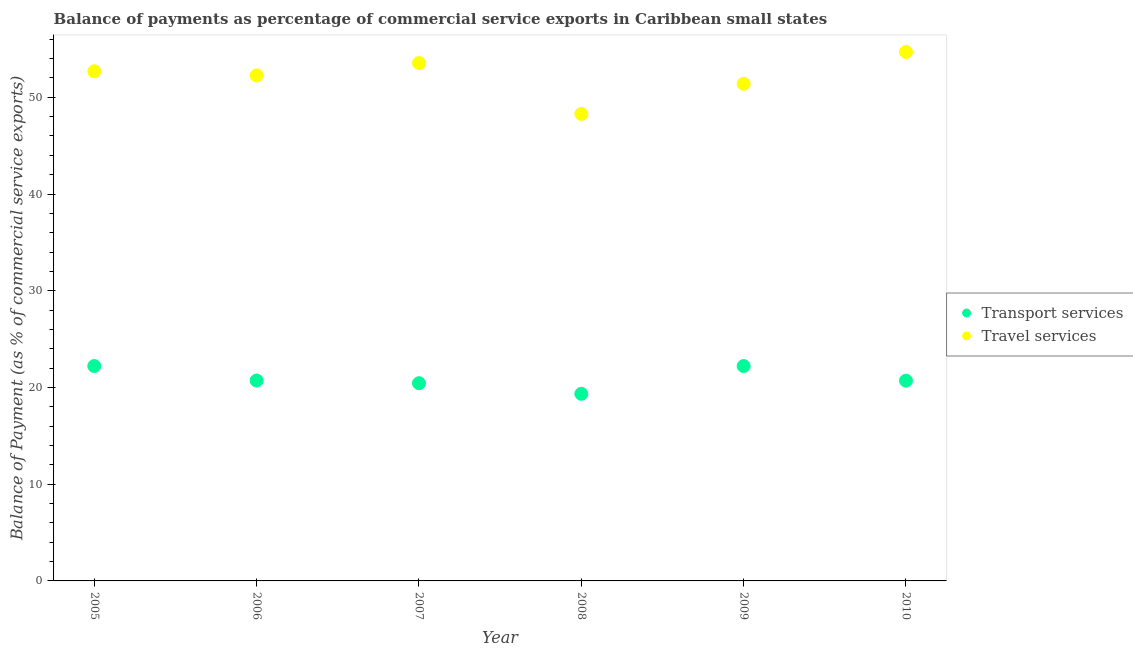What is the balance of payments of transport services in 2006?
Make the answer very short. 20.72. Across all years, what is the maximum balance of payments of transport services?
Make the answer very short. 22.22. Across all years, what is the minimum balance of payments of transport services?
Make the answer very short. 19.34. What is the total balance of payments of transport services in the graph?
Provide a short and direct response. 125.64. What is the difference between the balance of payments of travel services in 2006 and that in 2010?
Keep it short and to the point. -2.42. What is the difference between the balance of payments of travel services in 2010 and the balance of payments of transport services in 2005?
Provide a succinct answer. 32.47. What is the average balance of payments of transport services per year?
Provide a succinct answer. 20.94. In the year 2010, what is the difference between the balance of payments of travel services and balance of payments of transport services?
Provide a short and direct response. 33.98. In how many years, is the balance of payments of travel services greater than 6 %?
Make the answer very short. 6. What is the ratio of the balance of payments of travel services in 2006 to that in 2009?
Ensure brevity in your answer.  1.02. Is the difference between the balance of payments of transport services in 2007 and 2010 greater than the difference between the balance of payments of travel services in 2007 and 2010?
Your answer should be very brief. Yes. What is the difference between the highest and the second highest balance of payments of travel services?
Provide a short and direct response. 1.15. What is the difference between the highest and the lowest balance of payments of transport services?
Offer a very short reply. 2.87. Is the balance of payments of travel services strictly greater than the balance of payments of transport services over the years?
Provide a short and direct response. Yes. How many dotlines are there?
Ensure brevity in your answer.  2. How many years are there in the graph?
Provide a succinct answer. 6. What is the difference between two consecutive major ticks on the Y-axis?
Your answer should be compact. 10. Does the graph contain any zero values?
Your answer should be compact. No. Does the graph contain grids?
Offer a terse response. No. Where does the legend appear in the graph?
Your response must be concise. Center right. How are the legend labels stacked?
Ensure brevity in your answer.  Vertical. What is the title of the graph?
Offer a very short reply. Balance of payments as percentage of commercial service exports in Caribbean small states. Does "Manufacturing industries and construction" appear as one of the legend labels in the graph?
Provide a short and direct response. No. What is the label or title of the Y-axis?
Provide a short and direct response. Balance of Payment (as % of commercial service exports). What is the Balance of Payment (as % of commercial service exports) of Transport services in 2005?
Your answer should be very brief. 22.22. What is the Balance of Payment (as % of commercial service exports) in Travel services in 2005?
Provide a succinct answer. 52.69. What is the Balance of Payment (as % of commercial service exports) in Transport services in 2006?
Your answer should be compact. 20.72. What is the Balance of Payment (as % of commercial service exports) of Travel services in 2006?
Your response must be concise. 52.27. What is the Balance of Payment (as % of commercial service exports) in Transport services in 2007?
Offer a terse response. 20.44. What is the Balance of Payment (as % of commercial service exports) of Travel services in 2007?
Offer a very short reply. 53.54. What is the Balance of Payment (as % of commercial service exports) in Transport services in 2008?
Your answer should be very brief. 19.34. What is the Balance of Payment (as % of commercial service exports) of Travel services in 2008?
Keep it short and to the point. 48.28. What is the Balance of Payment (as % of commercial service exports) in Transport services in 2009?
Make the answer very short. 22.22. What is the Balance of Payment (as % of commercial service exports) of Travel services in 2009?
Offer a very short reply. 51.4. What is the Balance of Payment (as % of commercial service exports) in Transport services in 2010?
Make the answer very short. 20.71. What is the Balance of Payment (as % of commercial service exports) in Travel services in 2010?
Ensure brevity in your answer.  54.69. Across all years, what is the maximum Balance of Payment (as % of commercial service exports) in Transport services?
Provide a short and direct response. 22.22. Across all years, what is the maximum Balance of Payment (as % of commercial service exports) in Travel services?
Give a very brief answer. 54.69. Across all years, what is the minimum Balance of Payment (as % of commercial service exports) of Transport services?
Your response must be concise. 19.34. Across all years, what is the minimum Balance of Payment (as % of commercial service exports) of Travel services?
Your answer should be very brief. 48.28. What is the total Balance of Payment (as % of commercial service exports) in Transport services in the graph?
Your response must be concise. 125.64. What is the total Balance of Payment (as % of commercial service exports) in Travel services in the graph?
Your response must be concise. 312.86. What is the difference between the Balance of Payment (as % of commercial service exports) of Transport services in 2005 and that in 2006?
Your response must be concise. 1.5. What is the difference between the Balance of Payment (as % of commercial service exports) in Travel services in 2005 and that in 2006?
Provide a short and direct response. 0.42. What is the difference between the Balance of Payment (as % of commercial service exports) of Transport services in 2005 and that in 2007?
Provide a short and direct response. 1.78. What is the difference between the Balance of Payment (as % of commercial service exports) in Travel services in 2005 and that in 2007?
Ensure brevity in your answer.  -0.85. What is the difference between the Balance of Payment (as % of commercial service exports) in Transport services in 2005 and that in 2008?
Offer a very short reply. 2.87. What is the difference between the Balance of Payment (as % of commercial service exports) in Travel services in 2005 and that in 2008?
Offer a very short reply. 4.41. What is the difference between the Balance of Payment (as % of commercial service exports) in Transport services in 2005 and that in 2009?
Give a very brief answer. 0. What is the difference between the Balance of Payment (as % of commercial service exports) of Travel services in 2005 and that in 2009?
Provide a succinct answer. 1.29. What is the difference between the Balance of Payment (as % of commercial service exports) in Transport services in 2005 and that in 2010?
Ensure brevity in your answer.  1.51. What is the difference between the Balance of Payment (as % of commercial service exports) of Travel services in 2005 and that in 2010?
Make the answer very short. -1.99. What is the difference between the Balance of Payment (as % of commercial service exports) in Transport services in 2006 and that in 2007?
Provide a succinct answer. 0.28. What is the difference between the Balance of Payment (as % of commercial service exports) in Travel services in 2006 and that in 2007?
Ensure brevity in your answer.  -1.27. What is the difference between the Balance of Payment (as % of commercial service exports) of Transport services in 2006 and that in 2008?
Ensure brevity in your answer.  1.37. What is the difference between the Balance of Payment (as % of commercial service exports) of Travel services in 2006 and that in 2008?
Your answer should be compact. 3.98. What is the difference between the Balance of Payment (as % of commercial service exports) in Transport services in 2006 and that in 2009?
Offer a terse response. -1.5. What is the difference between the Balance of Payment (as % of commercial service exports) in Travel services in 2006 and that in 2009?
Your answer should be very brief. 0.87. What is the difference between the Balance of Payment (as % of commercial service exports) of Travel services in 2006 and that in 2010?
Your answer should be compact. -2.42. What is the difference between the Balance of Payment (as % of commercial service exports) in Transport services in 2007 and that in 2008?
Your response must be concise. 1.1. What is the difference between the Balance of Payment (as % of commercial service exports) in Travel services in 2007 and that in 2008?
Your response must be concise. 5.26. What is the difference between the Balance of Payment (as % of commercial service exports) in Transport services in 2007 and that in 2009?
Your answer should be compact. -1.78. What is the difference between the Balance of Payment (as % of commercial service exports) of Travel services in 2007 and that in 2009?
Your response must be concise. 2.14. What is the difference between the Balance of Payment (as % of commercial service exports) in Transport services in 2007 and that in 2010?
Provide a succinct answer. -0.27. What is the difference between the Balance of Payment (as % of commercial service exports) in Travel services in 2007 and that in 2010?
Give a very brief answer. -1.15. What is the difference between the Balance of Payment (as % of commercial service exports) of Transport services in 2008 and that in 2009?
Make the answer very short. -2.87. What is the difference between the Balance of Payment (as % of commercial service exports) in Travel services in 2008 and that in 2009?
Offer a very short reply. -3.12. What is the difference between the Balance of Payment (as % of commercial service exports) in Transport services in 2008 and that in 2010?
Give a very brief answer. -1.36. What is the difference between the Balance of Payment (as % of commercial service exports) of Travel services in 2008 and that in 2010?
Give a very brief answer. -6.4. What is the difference between the Balance of Payment (as % of commercial service exports) in Transport services in 2009 and that in 2010?
Make the answer very short. 1.51. What is the difference between the Balance of Payment (as % of commercial service exports) in Travel services in 2009 and that in 2010?
Your answer should be very brief. -3.29. What is the difference between the Balance of Payment (as % of commercial service exports) of Transport services in 2005 and the Balance of Payment (as % of commercial service exports) of Travel services in 2006?
Offer a very short reply. -30.05. What is the difference between the Balance of Payment (as % of commercial service exports) in Transport services in 2005 and the Balance of Payment (as % of commercial service exports) in Travel services in 2007?
Your answer should be very brief. -31.32. What is the difference between the Balance of Payment (as % of commercial service exports) of Transport services in 2005 and the Balance of Payment (as % of commercial service exports) of Travel services in 2008?
Provide a short and direct response. -26.07. What is the difference between the Balance of Payment (as % of commercial service exports) of Transport services in 2005 and the Balance of Payment (as % of commercial service exports) of Travel services in 2009?
Ensure brevity in your answer.  -29.18. What is the difference between the Balance of Payment (as % of commercial service exports) in Transport services in 2005 and the Balance of Payment (as % of commercial service exports) in Travel services in 2010?
Give a very brief answer. -32.47. What is the difference between the Balance of Payment (as % of commercial service exports) of Transport services in 2006 and the Balance of Payment (as % of commercial service exports) of Travel services in 2007?
Provide a succinct answer. -32.82. What is the difference between the Balance of Payment (as % of commercial service exports) of Transport services in 2006 and the Balance of Payment (as % of commercial service exports) of Travel services in 2008?
Ensure brevity in your answer.  -27.57. What is the difference between the Balance of Payment (as % of commercial service exports) in Transport services in 2006 and the Balance of Payment (as % of commercial service exports) in Travel services in 2009?
Your answer should be very brief. -30.68. What is the difference between the Balance of Payment (as % of commercial service exports) in Transport services in 2006 and the Balance of Payment (as % of commercial service exports) in Travel services in 2010?
Provide a succinct answer. -33.97. What is the difference between the Balance of Payment (as % of commercial service exports) of Transport services in 2007 and the Balance of Payment (as % of commercial service exports) of Travel services in 2008?
Ensure brevity in your answer.  -27.84. What is the difference between the Balance of Payment (as % of commercial service exports) in Transport services in 2007 and the Balance of Payment (as % of commercial service exports) in Travel services in 2009?
Give a very brief answer. -30.96. What is the difference between the Balance of Payment (as % of commercial service exports) of Transport services in 2007 and the Balance of Payment (as % of commercial service exports) of Travel services in 2010?
Ensure brevity in your answer.  -34.25. What is the difference between the Balance of Payment (as % of commercial service exports) in Transport services in 2008 and the Balance of Payment (as % of commercial service exports) in Travel services in 2009?
Keep it short and to the point. -32.05. What is the difference between the Balance of Payment (as % of commercial service exports) in Transport services in 2008 and the Balance of Payment (as % of commercial service exports) in Travel services in 2010?
Your response must be concise. -35.34. What is the difference between the Balance of Payment (as % of commercial service exports) in Transport services in 2009 and the Balance of Payment (as % of commercial service exports) in Travel services in 2010?
Your answer should be compact. -32.47. What is the average Balance of Payment (as % of commercial service exports) in Transport services per year?
Offer a terse response. 20.94. What is the average Balance of Payment (as % of commercial service exports) of Travel services per year?
Keep it short and to the point. 52.14. In the year 2005, what is the difference between the Balance of Payment (as % of commercial service exports) in Transport services and Balance of Payment (as % of commercial service exports) in Travel services?
Offer a very short reply. -30.47. In the year 2006, what is the difference between the Balance of Payment (as % of commercial service exports) in Transport services and Balance of Payment (as % of commercial service exports) in Travel services?
Give a very brief answer. -31.55. In the year 2007, what is the difference between the Balance of Payment (as % of commercial service exports) of Transport services and Balance of Payment (as % of commercial service exports) of Travel services?
Provide a short and direct response. -33.1. In the year 2008, what is the difference between the Balance of Payment (as % of commercial service exports) in Transport services and Balance of Payment (as % of commercial service exports) in Travel services?
Your response must be concise. -28.94. In the year 2009, what is the difference between the Balance of Payment (as % of commercial service exports) of Transport services and Balance of Payment (as % of commercial service exports) of Travel services?
Offer a very short reply. -29.18. In the year 2010, what is the difference between the Balance of Payment (as % of commercial service exports) of Transport services and Balance of Payment (as % of commercial service exports) of Travel services?
Keep it short and to the point. -33.98. What is the ratio of the Balance of Payment (as % of commercial service exports) of Transport services in 2005 to that in 2006?
Your answer should be compact. 1.07. What is the ratio of the Balance of Payment (as % of commercial service exports) in Travel services in 2005 to that in 2006?
Make the answer very short. 1.01. What is the ratio of the Balance of Payment (as % of commercial service exports) of Transport services in 2005 to that in 2007?
Offer a terse response. 1.09. What is the ratio of the Balance of Payment (as % of commercial service exports) of Travel services in 2005 to that in 2007?
Keep it short and to the point. 0.98. What is the ratio of the Balance of Payment (as % of commercial service exports) in Transport services in 2005 to that in 2008?
Your answer should be very brief. 1.15. What is the ratio of the Balance of Payment (as % of commercial service exports) of Travel services in 2005 to that in 2008?
Ensure brevity in your answer.  1.09. What is the ratio of the Balance of Payment (as % of commercial service exports) in Transport services in 2005 to that in 2009?
Your answer should be compact. 1. What is the ratio of the Balance of Payment (as % of commercial service exports) of Travel services in 2005 to that in 2009?
Provide a short and direct response. 1.03. What is the ratio of the Balance of Payment (as % of commercial service exports) of Transport services in 2005 to that in 2010?
Your answer should be very brief. 1.07. What is the ratio of the Balance of Payment (as % of commercial service exports) in Travel services in 2005 to that in 2010?
Keep it short and to the point. 0.96. What is the ratio of the Balance of Payment (as % of commercial service exports) in Transport services in 2006 to that in 2007?
Provide a short and direct response. 1.01. What is the ratio of the Balance of Payment (as % of commercial service exports) of Travel services in 2006 to that in 2007?
Your answer should be compact. 0.98. What is the ratio of the Balance of Payment (as % of commercial service exports) of Transport services in 2006 to that in 2008?
Offer a very short reply. 1.07. What is the ratio of the Balance of Payment (as % of commercial service exports) of Travel services in 2006 to that in 2008?
Your answer should be very brief. 1.08. What is the ratio of the Balance of Payment (as % of commercial service exports) in Transport services in 2006 to that in 2009?
Keep it short and to the point. 0.93. What is the ratio of the Balance of Payment (as % of commercial service exports) of Travel services in 2006 to that in 2009?
Your answer should be compact. 1.02. What is the ratio of the Balance of Payment (as % of commercial service exports) of Travel services in 2006 to that in 2010?
Provide a short and direct response. 0.96. What is the ratio of the Balance of Payment (as % of commercial service exports) in Transport services in 2007 to that in 2008?
Give a very brief answer. 1.06. What is the ratio of the Balance of Payment (as % of commercial service exports) in Travel services in 2007 to that in 2008?
Give a very brief answer. 1.11. What is the ratio of the Balance of Payment (as % of commercial service exports) in Travel services in 2007 to that in 2009?
Your answer should be very brief. 1.04. What is the ratio of the Balance of Payment (as % of commercial service exports) of Transport services in 2007 to that in 2010?
Provide a succinct answer. 0.99. What is the ratio of the Balance of Payment (as % of commercial service exports) in Transport services in 2008 to that in 2009?
Offer a terse response. 0.87. What is the ratio of the Balance of Payment (as % of commercial service exports) of Travel services in 2008 to that in 2009?
Your answer should be compact. 0.94. What is the ratio of the Balance of Payment (as % of commercial service exports) in Transport services in 2008 to that in 2010?
Provide a succinct answer. 0.93. What is the ratio of the Balance of Payment (as % of commercial service exports) in Travel services in 2008 to that in 2010?
Your response must be concise. 0.88. What is the ratio of the Balance of Payment (as % of commercial service exports) in Transport services in 2009 to that in 2010?
Your answer should be very brief. 1.07. What is the ratio of the Balance of Payment (as % of commercial service exports) in Travel services in 2009 to that in 2010?
Provide a short and direct response. 0.94. What is the difference between the highest and the second highest Balance of Payment (as % of commercial service exports) of Transport services?
Keep it short and to the point. 0. What is the difference between the highest and the second highest Balance of Payment (as % of commercial service exports) of Travel services?
Provide a succinct answer. 1.15. What is the difference between the highest and the lowest Balance of Payment (as % of commercial service exports) of Transport services?
Your answer should be compact. 2.87. What is the difference between the highest and the lowest Balance of Payment (as % of commercial service exports) in Travel services?
Your response must be concise. 6.4. 